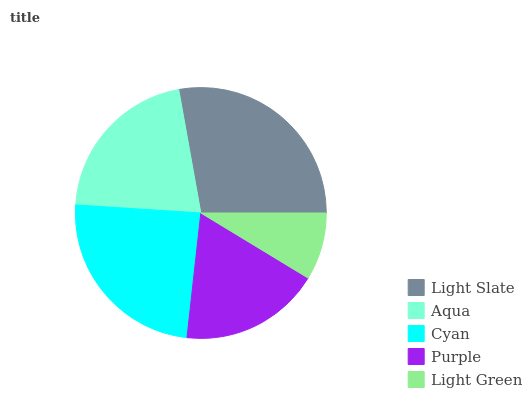Is Light Green the minimum?
Answer yes or no. Yes. Is Light Slate the maximum?
Answer yes or no. Yes. Is Aqua the minimum?
Answer yes or no. No. Is Aqua the maximum?
Answer yes or no. No. Is Light Slate greater than Aqua?
Answer yes or no. Yes. Is Aqua less than Light Slate?
Answer yes or no. Yes. Is Aqua greater than Light Slate?
Answer yes or no. No. Is Light Slate less than Aqua?
Answer yes or no. No. Is Aqua the high median?
Answer yes or no. Yes. Is Aqua the low median?
Answer yes or no. Yes. Is Light Green the high median?
Answer yes or no. No. Is Light Green the low median?
Answer yes or no. No. 